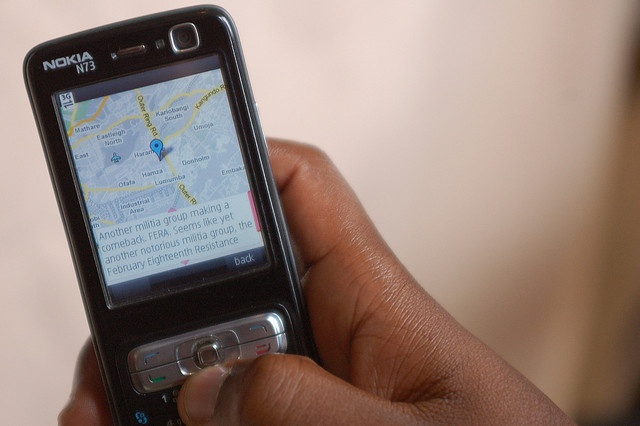Describe the objects in this image and their specific colors. I can see cell phone in lightgray, black, darkgray, and gray tones and people in lightgray, maroon, and brown tones in this image. 